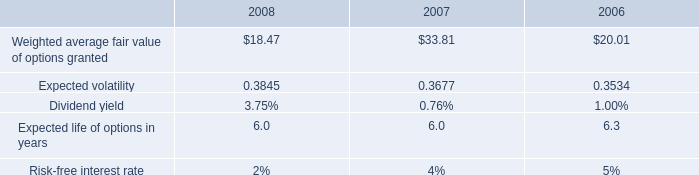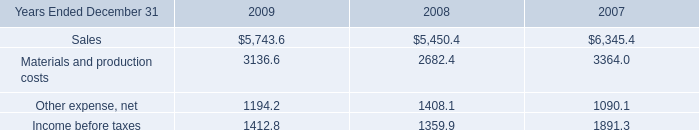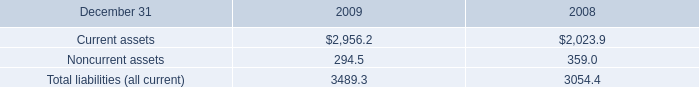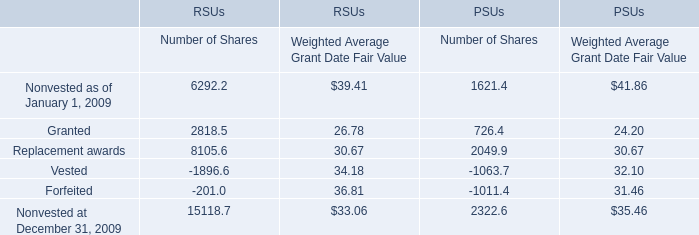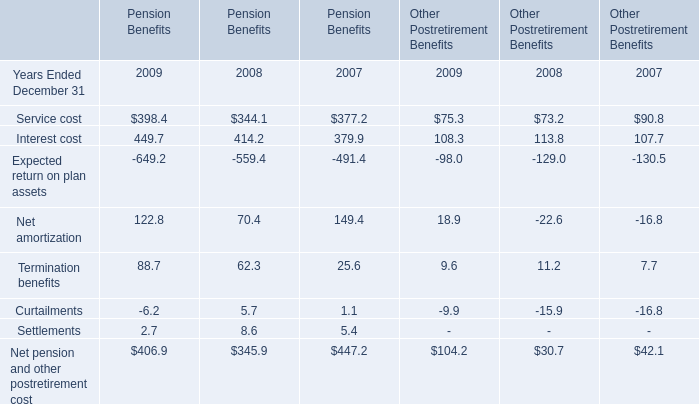What's the average of Nonvested at December 31, 2009 of RSUs Number of Shares, and Current assets of 2008 ? 
Computations: ((15118.7 + 2023.9) / 2)
Answer: 8571.3. 